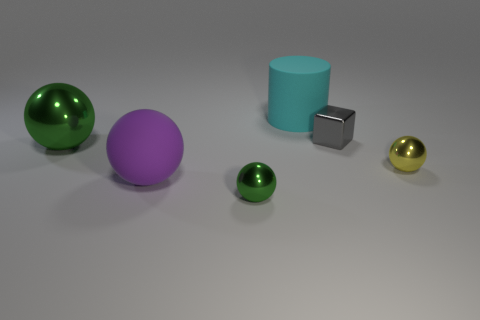Subtract all metallic spheres. How many spheres are left? 1 Subtract all yellow balls. How many balls are left? 3 Subtract all purple blocks. How many green spheres are left? 2 Add 2 large cyan rubber objects. How many objects exist? 8 Subtract all blocks. How many objects are left? 5 Add 5 big green things. How many big green things exist? 6 Subtract 0 brown spheres. How many objects are left? 6 Subtract all gray cylinders. Subtract all cyan cubes. How many cylinders are left? 1 Subtract all big metal objects. Subtract all tiny green spheres. How many objects are left? 4 Add 6 purple objects. How many purple objects are left? 7 